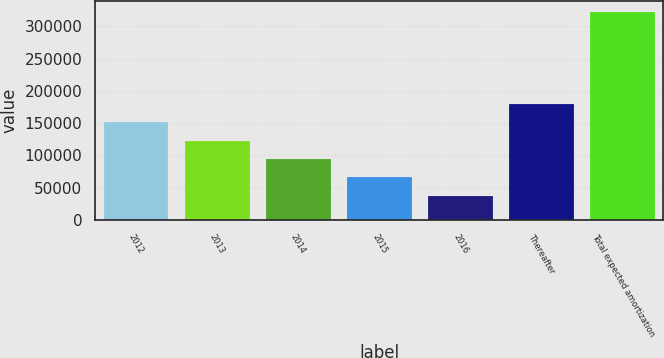<chart> <loc_0><loc_0><loc_500><loc_500><bar_chart><fcel>2012<fcel>2013<fcel>2014<fcel>2015<fcel>2016<fcel>Thereafter<fcel>Total expected amortization<nl><fcel>151431<fcel>122864<fcel>94297.6<fcel>65730.8<fcel>37164<fcel>179998<fcel>322832<nl></chart> 